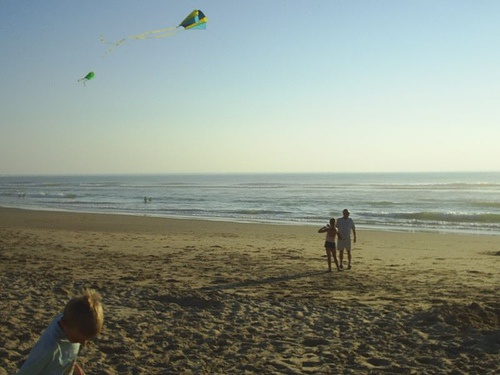Describe the objects in this image and their specific colors. I can see people in gray, black, darkblue, and olive tones, people in gray and black tones, kite in gray, darkgray, teal, blue, and darkgreen tones, people in gray and black tones, and kite in gray, darkgreen, green, darkgray, and turquoise tones in this image. 